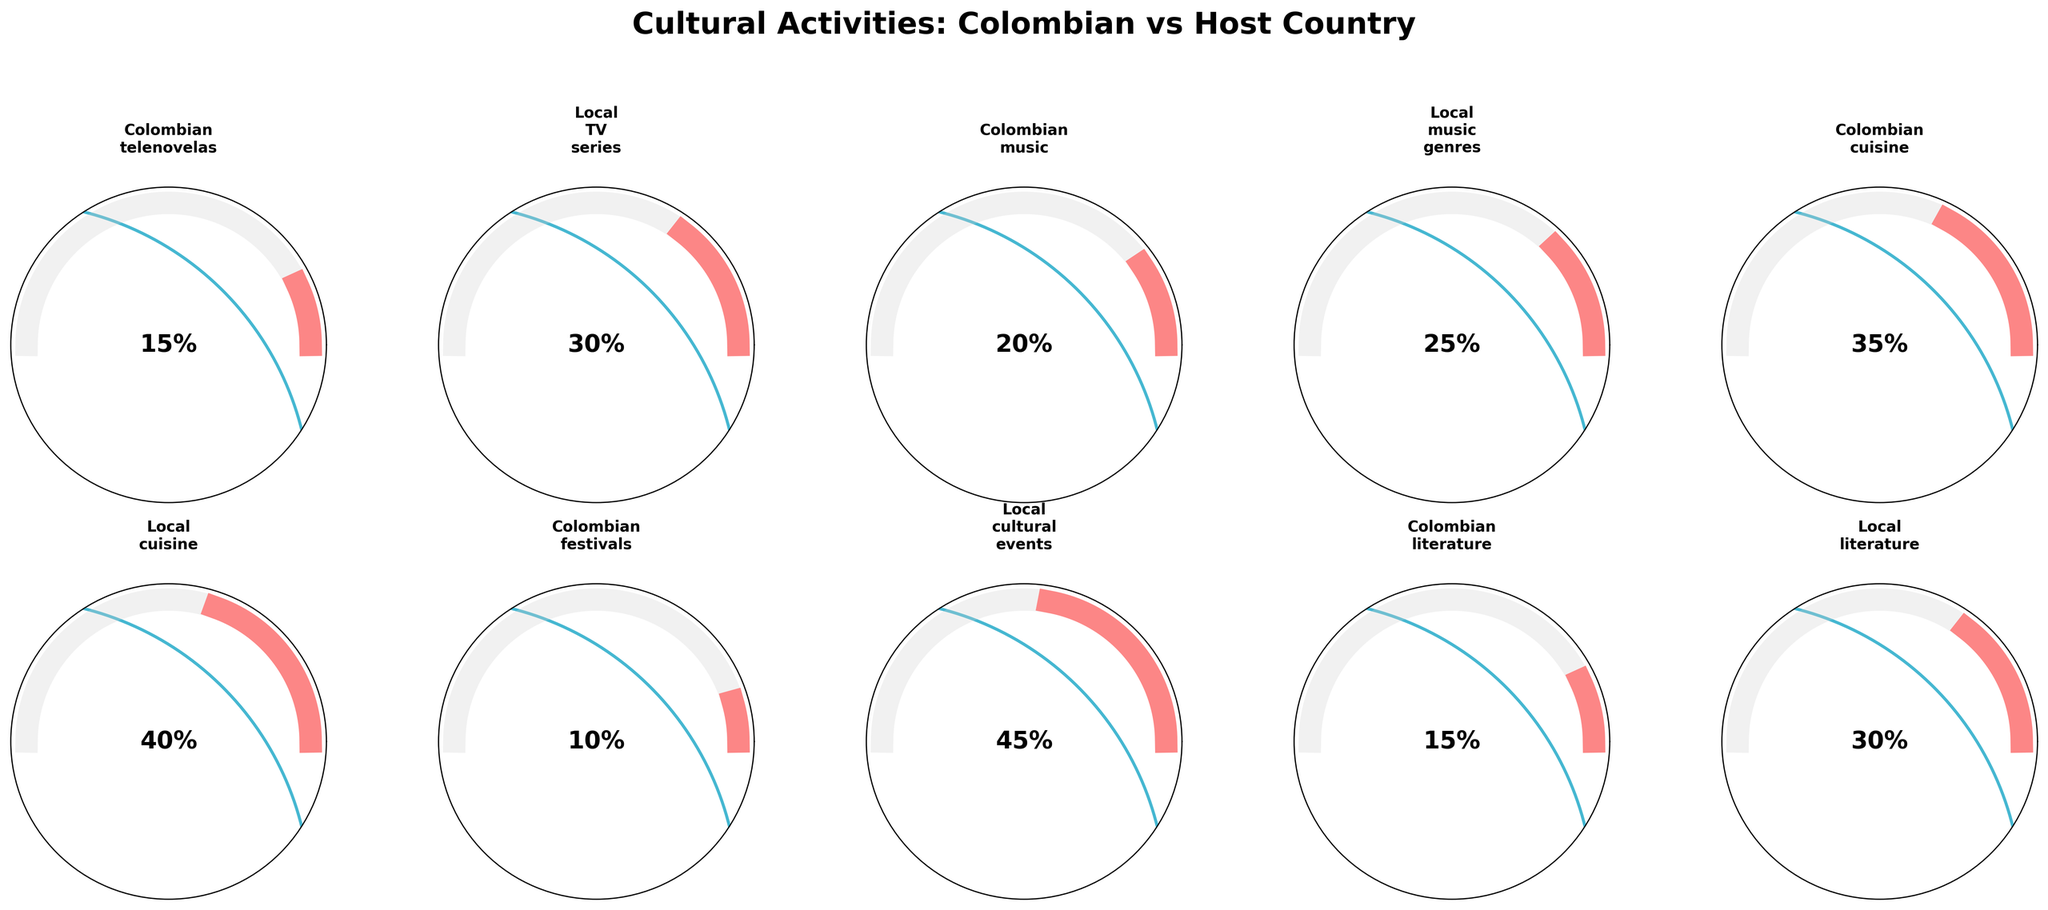What is the percentage of time spent on Colombian telenovelas? Read the gauge for "Colombian telenovelas" to find the indicated percentage.
Answer: 15% Which activity has the highest time percentage for local culture? Compare the percentages for all local cultural activities and find the highest one. Local cultural activities include local TV series, local music genres, local cuisine, local cultural events, and local literature.
Answer: Local cultural events How does the time spent on Colombian literature compare to that on local literature? Note the percentage values for both Colombian literature and local literature, and compare them directly.
Answer: Local literature has a higher percentage (30% compared to 15%) What is the combined percentage for time spent on all local cultural activities? Sum the percentages for all local cultural activities (30% for local TV series, 25% for local music genres, 40% for local cuisine, 45% for local cultural events, and 30% for local literature).
Answer: 170% What is the average time percentage spent on Colombian activities? Calculate the average by summing the percentages for all Colombian activities (15% for Colombian telenovelas, 20% for Colombian music, 35% for Colombian cuisine, 10% for Colombian festivals, and 15% for Colombian literature), and divide by the number of activities (5).
Answer: 19% Which activity has the lowest time percentage? Compare all listed percentages and identify the smallest one.
Answer: Colombian festivals Is there a greater percentage of time spent on local music genres or Colombian music? Compare the percentage values for local music genres and Colombian music.
Answer: Local music genres (25% vs. 20%) Do expatriates spend more time on local cuisine or Colombian telenovelas? Directly compare the percentages for local cuisine and Colombian telenovelas.
Answer: Local cuisine (40% vs. 15%) Do expatriates spend more time on Colombian cuisine or Colombian music? Directly compare the percentages for Colombian cuisine and Colombian music.
Answer: Colombian cuisine (35% vs. 20%) What is the difference in time percentage between local cultural events and Colombian festivals? Subtract the percentage of Colombian festivals from that of local cultural events (45% - 10%).
Answer: 35% 